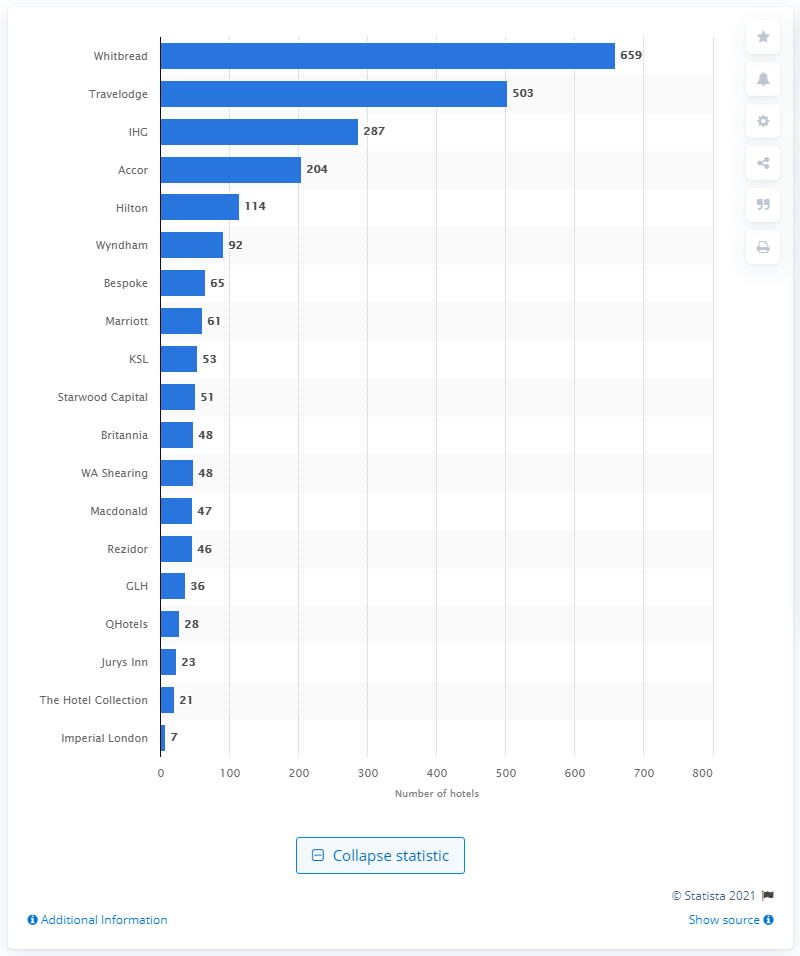Identify some key points in this picture. Whitbread owns 659 hotels. 